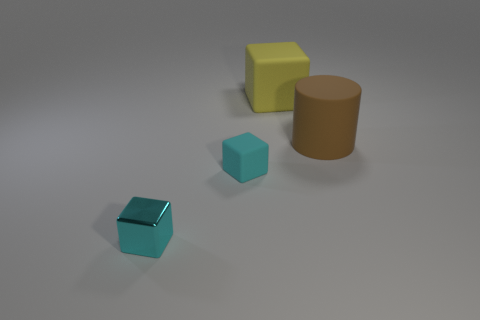What number of other things are there of the same material as the cylinder
Keep it short and to the point. 2. Are there more large blocks than tiny cyan objects?
Provide a succinct answer. No. Is the color of the tiny cube to the right of the tiny metal block the same as the shiny block?
Give a very brief answer. Yes. The large rubber cube has what color?
Offer a terse response. Yellow. Are there any tiny things left of the matte cube that is in front of the cylinder?
Your answer should be compact. Yes. There is a big brown matte object that is right of the object that is behind the rubber cylinder; what is its shape?
Offer a very short reply. Cylinder. Is the number of large green matte cubes less than the number of shiny cubes?
Provide a succinct answer. Yes. Does the yellow block have the same material as the brown object?
Provide a short and direct response. Yes. There is a block that is in front of the large matte cube and behind the metallic thing; what color is it?
Provide a succinct answer. Cyan. Are there any yellow blocks of the same size as the cylinder?
Keep it short and to the point. Yes. 